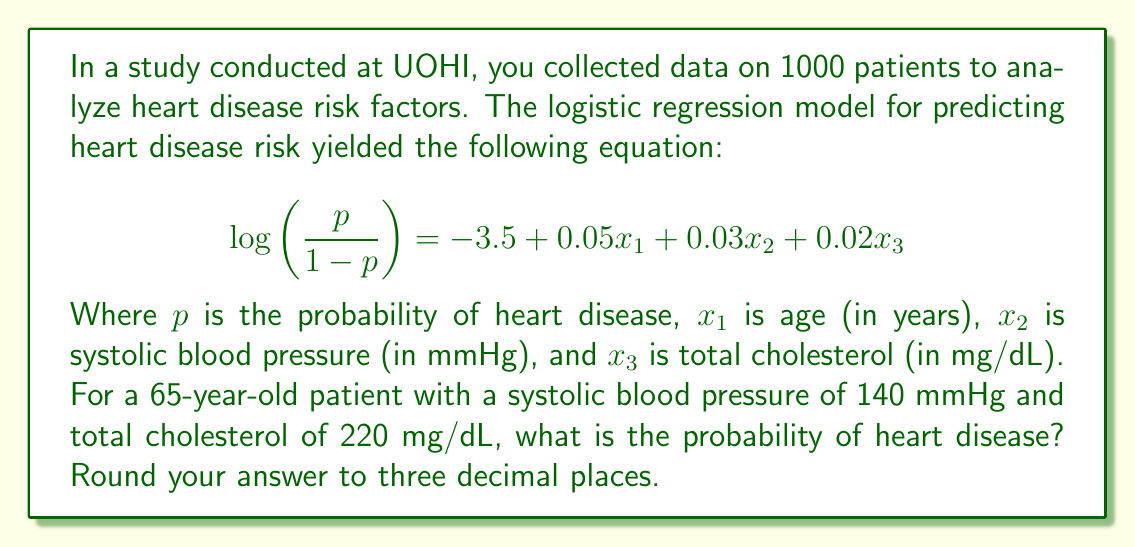Teach me how to tackle this problem. Let's approach this step-by-step:

1) We have the logistic regression equation:
   $$\log\left(\frac{p}{1-p}\right) = -3.5 + 0.05x_1 + 0.03x_2 + 0.02x_3$$

2) Let's substitute the given values:
   $x_1 = 65$ (age)
   $x_2 = 140$ (systolic blood pressure)
   $x_3 = 220$ (total cholesterol)

3) Plugging these into the equation:
   $$\log\left(\frac{p}{1-p}\right) = -3.5 + 0.05(65) + 0.03(140) + 0.02(220)$$

4) Let's calculate the right side:
   $$\log\left(\frac{p}{1-p}\right) = -3.5 + 3.25 + 4.2 + 4.4 = 8.35$$

5) Now we have:
   $$\log\left(\frac{p}{1-p}\right) = 8.35$$

6) To solve for $p$, we need to apply the exponential function to both sides:
   $$\frac{p}{1-p} = e^{8.35}$$

7) Let's calculate $e^{8.35}$:
   $$\frac{p}{1-p} = 4232.72$$

8) Now we can solve for $p$:
   $$p = 4232.72(1-p)$$
   $$p = 4232.72 - 4232.72p$$
   $$4233.72p = 4232.72$$
   $$p = \frac{4232.72}{4233.72} = 0.99976$$

9) Rounding to three decimal places:
   $$p = 1.000$$
Answer: 1.000 